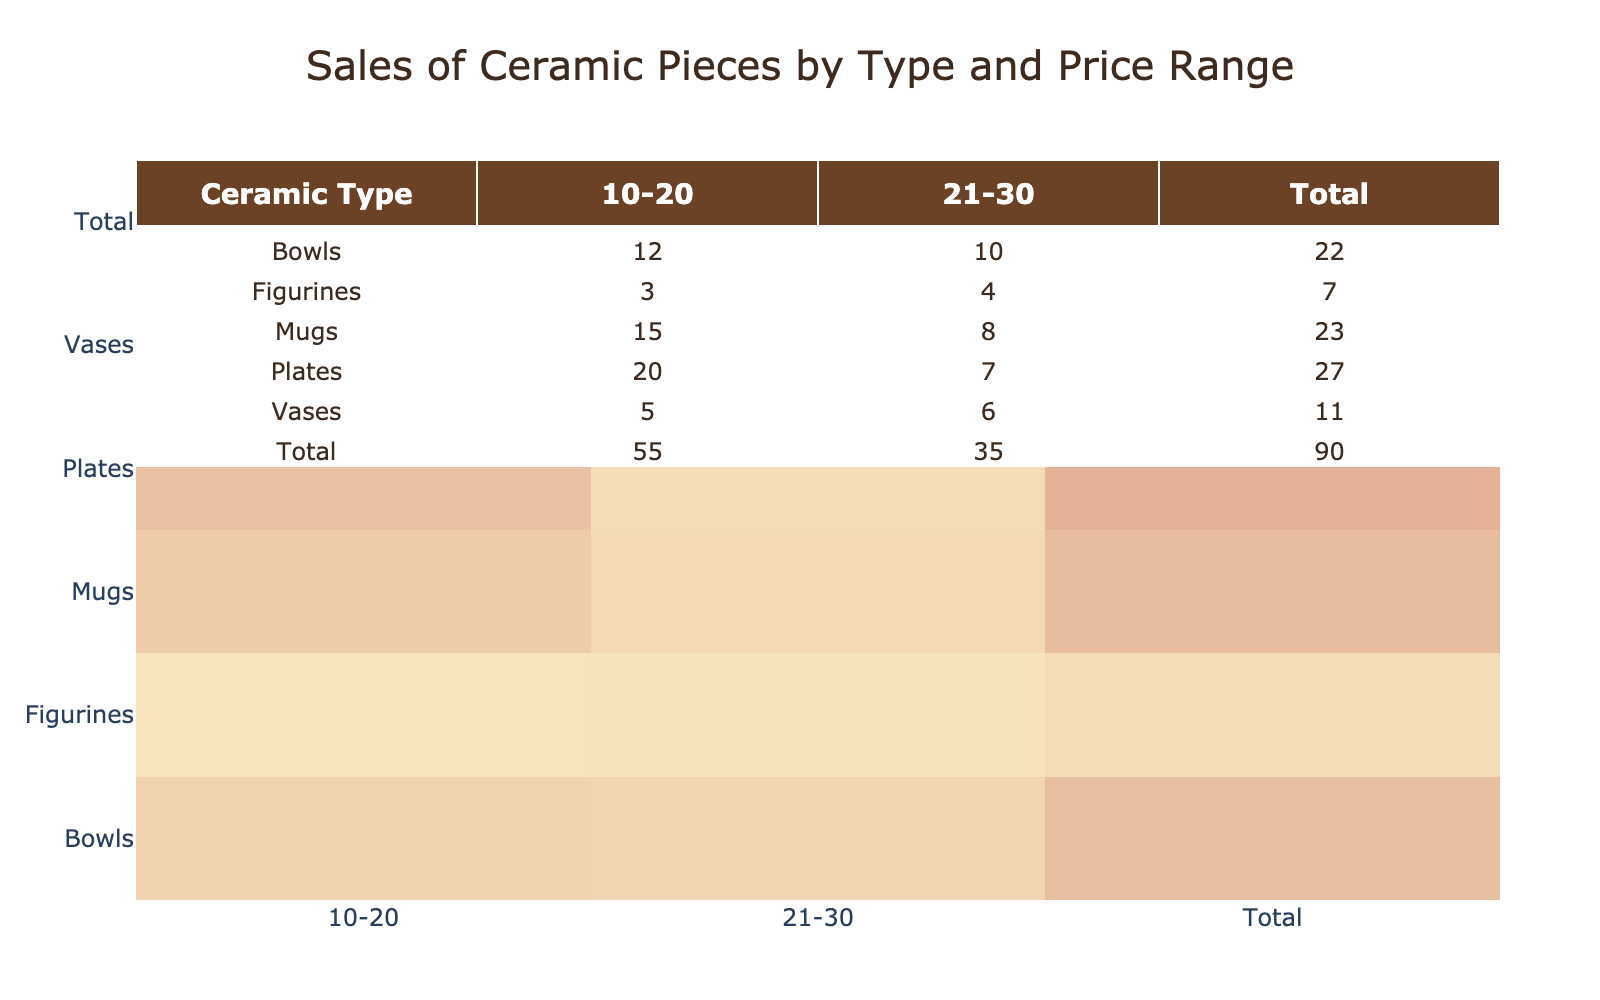What ceramic type had the highest sales in the price range 10-20? From the table, the sales counts for the price range 10-20 are: Mugs (15), Bowls (12), Plates (20), Vases (5), and Figurines (3). The highest is Plates with 20 sales.
Answer: Plates What is the total sales count of mugs in both price ranges? The sales counts for Mugs are 15 in the 10-20 range and 8 in the 21-30 range. Adding these gives 15 + 8 = 23.
Answer: 23 Did any ceramic type have more than 10 sales in the price range 21-30? Looking at the sales counts for the 21-30 range: Mugs (8), Bowls (10), Plates (7), Vases (6), and Figurines (4), none of them exceed 10.
Answer: No What is the difference in sales count between the highest and lowest selling ceramic types in the 21-30 price range? For the 21-30 range, the counts are: Mugs (8), Bowls (10), Plates (7), Vases (6), and Figurines (4). The highest is Bowl with 10, and the lowest is Figurine with 4. The difference is 10 - 4 = 6.
Answer: 6 What fraction of total sales came from bowls across both price ranges? The total sales of bowls are 12 in the 10-20 range and 10 in the 21-30 range, totaling 12 + 10 = 22. The grand total of all sales is 15 + 8 + 12 + 10 + 20 + 7 + 5 + 6 + 3 + 4 = 90. The fraction is 22/90, which simplifies to 11/45.
Answer: 11/45 How many types of ceramics had sales in the 10-20 price range that exceeded those in the 21-30 range? From the table, the sales in 10-20 are: Mugs (15), Bowls (12), Plates (20), Vases (5), Figurines (3). The sales in 21-30 are: Mugs (8), Bowls (10), Plates (7), Vases (6), Figurines (4). The types where sales in 10-20 exceed 21-30 are Mugs, Bowls, and Plates. Thus, there are 3 types.
Answer: 3 Is the total sales count of Vases higher than that of Figurines? The total sales count for Vases is 5 (10-20) + 6 (21-30) = 11. For Figurines, it's 3 (10-20) + 4 (21-30) = 7. Since 11 > 7, the statement is true.
Answer: Yes 